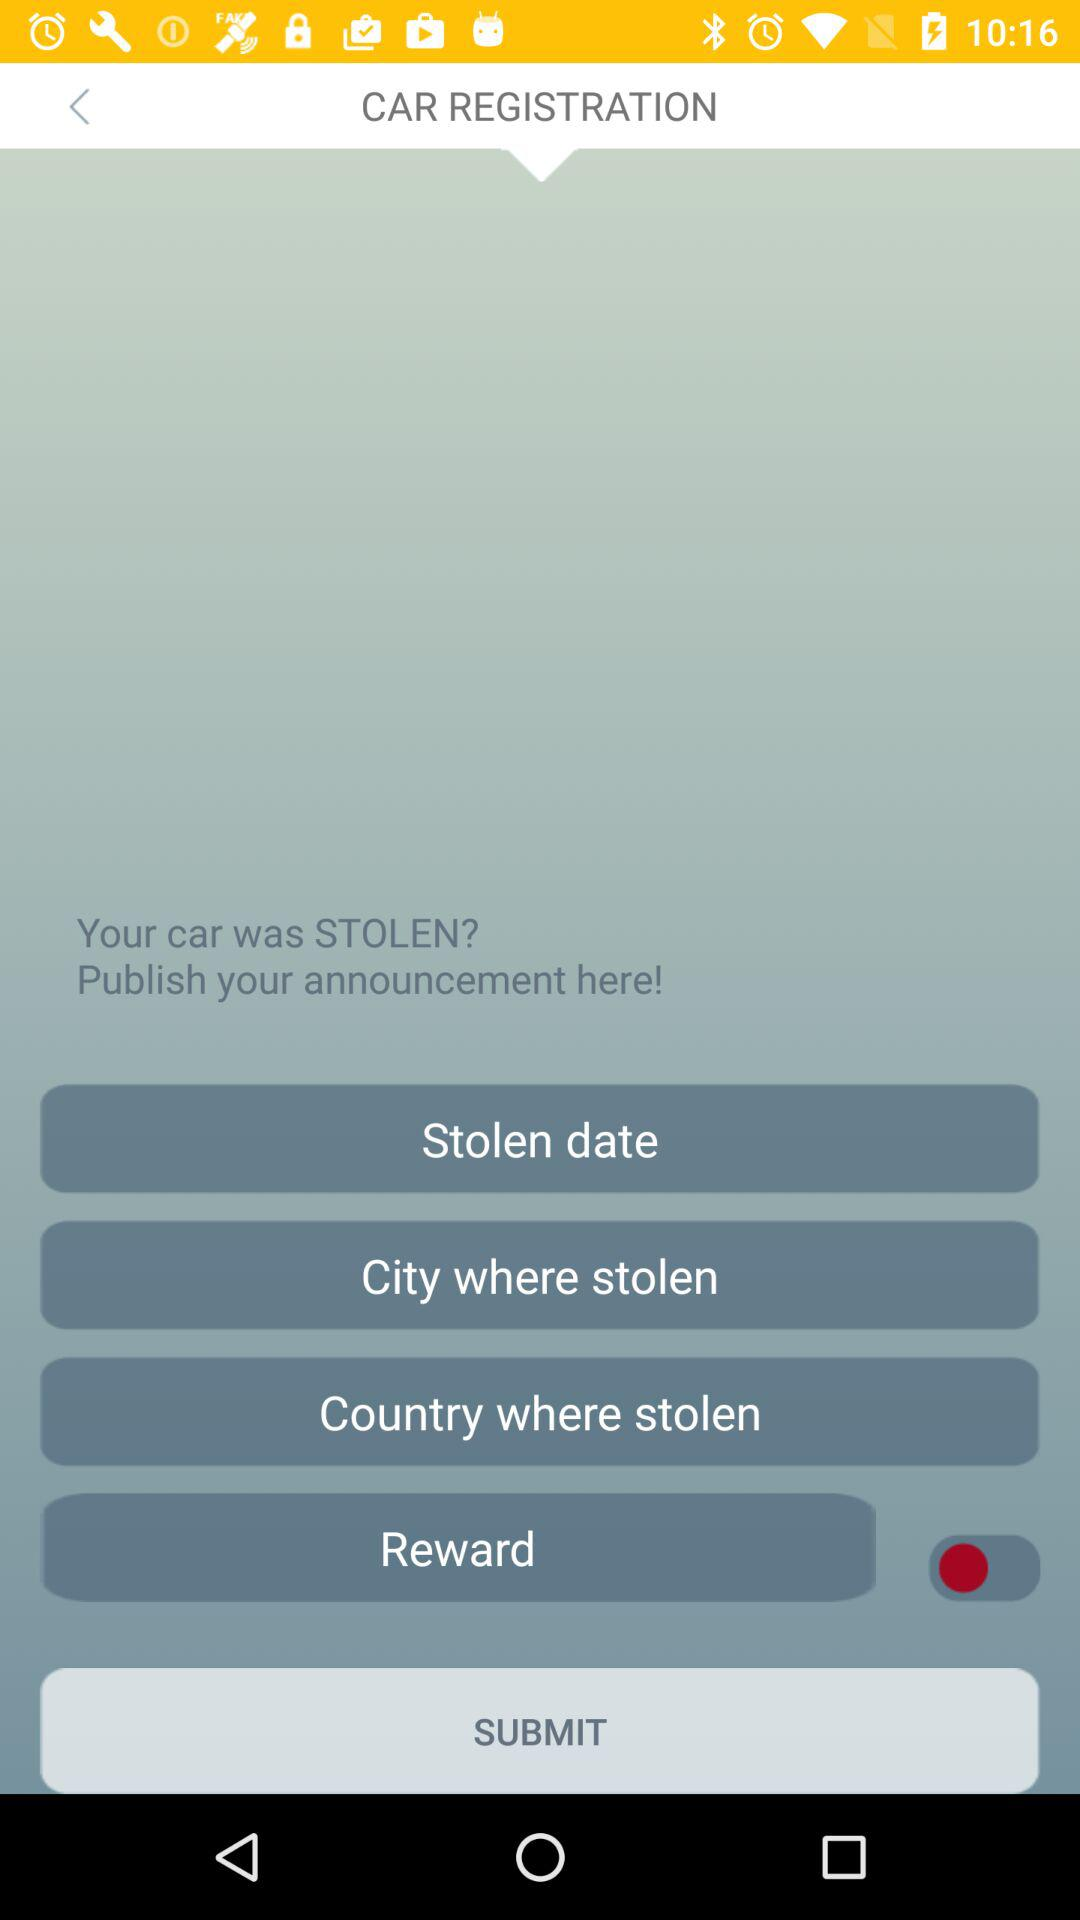How many steps must be completed to complete the form?
Answer the question using a single word or phrase. 6 